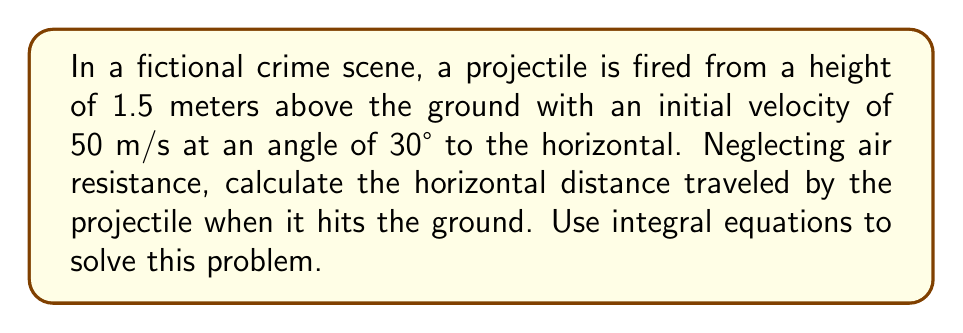What is the answer to this math problem? Let's approach this step-by-step using integral equations:

1) First, we need to set up our coordinate system. Let x be the horizontal distance and y be the vertical distance.

2) The equations of motion for a projectile are:

   $$\frac{d^2x}{dt^2} = 0$$
   $$\frac{d^2y}{dt^2} = -g$$

   where g is the acceleration due to gravity (9.8 m/s²).

3) Integrating these equations once with respect to time:

   $$\frac{dx}{dt} = v_0 \cos{\theta}$$
   $$\frac{dy}{dt} = v_0 \sin{\theta} - gt$$

   where $v_0$ is the initial velocity and $\theta$ is the launch angle.

4) Integrating again:

   $$x = (v_0 \cos{\theta})t$$
   $$y = (v_0 \sin{\theta})t - \frac{1}{2}gt^2 + y_0$$

   where $y_0$ is the initial height (1.5 m in this case).

5) We want to find x when y = 0 (when the projectile hits the ground). Substituting the given values:

   $$0 = (50 \sin{30°})t - \frac{1}{2}(9.8)t^2 + 1.5$$

6) Solving this quadratic equation:

   $$4.9t^2 - 25t - 1.5 = 0$$

   $$t = \frac{25 + \sqrt{625 + 29.4}}{9.8} \approx 5.28 \text{ seconds}$$

7) Now we can find x:

   $$x = (50 \cos{30°})(5.28) = 43.3 \cos{30°} \approx 228.3 \text{ meters}$$
Answer: 228.3 meters 